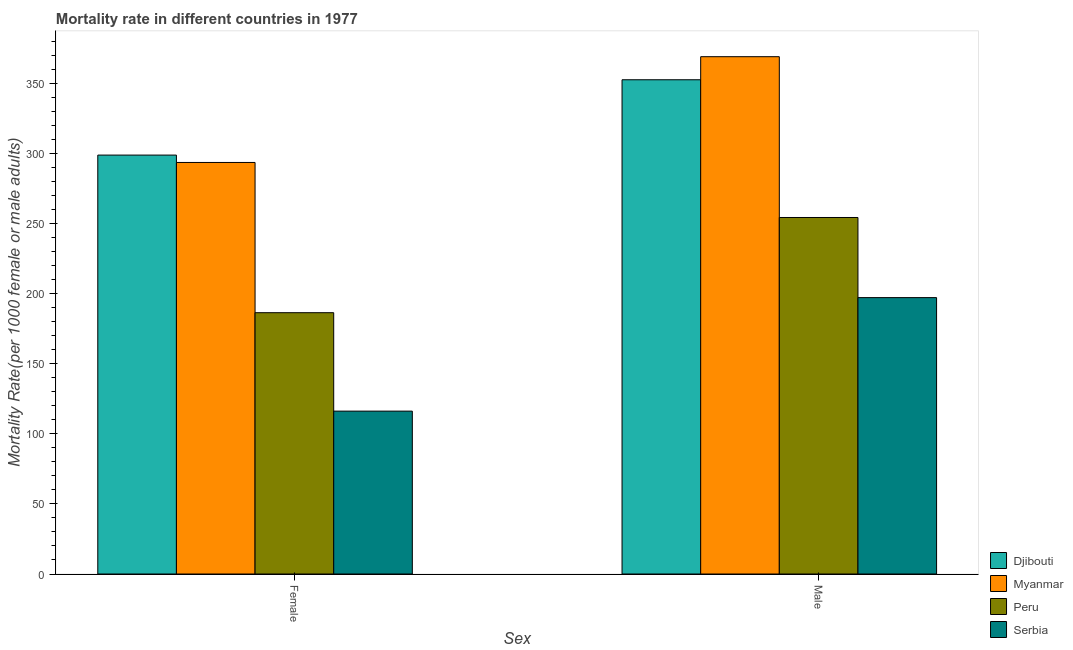Are the number of bars per tick equal to the number of legend labels?
Offer a very short reply. Yes. How many bars are there on the 1st tick from the right?
Offer a terse response. 4. What is the label of the 2nd group of bars from the left?
Provide a short and direct response. Male. What is the female mortality rate in Peru?
Your answer should be very brief. 186.59. Across all countries, what is the maximum female mortality rate?
Make the answer very short. 299.13. Across all countries, what is the minimum female mortality rate?
Provide a short and direct response. 116.3. In which country was the male mortality rate maximum?
Ensure brevity in your answer.  Myanmar. In which country was the female mortality rate minimum?
Provide a succinct answer. Serbia. What is the total female mortality rate in the graph?
Your response must be concise. 895.9. What is the difference between the male mortality rate in Peru and that in Myanmar?
Keep it short and to the point. -114.83. What is the difference between the female mortality rate in Serbia and the male mortality rate in Djibouti?
Provide a succinct answer. -236.64. What is the average male mortality rate per country?
Your answer should be compact. 293.57. What is the difference between the female mortality rate and male mortality rate in Peru?
Your answer should be very brief. -67.99. What is the ratio of the male mortality rate in Myanmar to that in Serbia?
Give a very brief answer. 1.87. What does the 4th bar from the left in Male represents?
Offer a very short reply. Serbia. What does the 2nd bar from the right in Male represents?
Offer a terse response. Peru. How many bars are there?
Your answer should be compact. 8. What is the difference between two consecutive major ticks on the Y-axis?
Your answer should be very brief. 50. Are the values on the major ticks of Y-axis written in scientific E-notation?
Keep it short and to the point. No. Does the graph contain any zero values?
Your response must be concise. No. Does the graph contain grids?
Provide a short and direct response. No. Where does the legend appear in the graph?
Provide a succinct answer. Bottom right. How many legend labels are there?
Keep it short and to the point. 4. How are the legend labels stacked?
Give a very brief answer. Vertical. What is the title of the graph?
Provide a succinct answer. Mortality rate in different countries in 1977. What is the label or title of the X-axis?
Your answer should be compact. Sex. What is the label or title of the Y-axis?
Make the answer very short. Mortality Rate(per 1000 female or male adults). What is the Mortality Rate(per 1000 female or male adults) of Djibouti in Female?
Make the answer very short. 299.13. What is the Mortality Rate(per 1000 female or male adults) in Myanmar in Female?
Make the answer very short. 293.88. What is the Mortality Rate(per 1000 female or male adults) in Peru in Female?
Ensure brevity in your answer.  186.59. What is the Mortality Rate(per 1000 female or male adults) in Serbia in Female?
Make the answer very short. 116.3. What is the Mortality Rate(per 1000 female or male adults) of Djibouti in Male?
Offer a very short reply. 352.94. What is the Mortality Rate(per 1000 female or male adults) of Myanmar in Male?
Offer a very short reply. 369.4. What is the Mortality Rate(per 1000 female or male adults) in Peru in Male?
Provide a succinct answer. 254.57. What is the Mortality Rate(per 1000 female or male adults) in Serbia in Male?
Ensure brevity in your answer.  197.36. Across all Sex, what is the maximum Mortality Rate(per 1000 female or male adults) of Djibouti?
Ensure brevity in your answer.  352.94. Across all Sex, what is the maximum Mortality Rate(per 1000 female or male adults) of Myanmar?
Keep it short and to the point. 369.4. Across all Sex, what is the maximum Mortality Rate(per 1000 female or male adults) in Peru?
Your answer should be very brief. 254.57. Across all Sex, what is the maximum Mortality Rate(per 1000 female or male adults) in Serbia?
Make the answer very short. 197.36. Across all Sex, what is the minimum Mortality Rate(per 1000 female or male adults) of Djibouti?
Keep it short and to the point. 299.13. Across all Sex, what is the minimum Mortality Rate(per 1000 female or male adults) in Myanmar?
Your response must be concise. 293.88. Across all Sex, what is the minimum Mortality Rate(per 1000 female or male adults) of Peru?
Your response must be concise. 186.59. Across all Sex, what is the minimum Mortality Rate(per 1000 female or male adults) in Serbia?
Your answer should be very brief. 116.3. What is the total Mortality Rate(per 1000 female or male adults) in Djibouti in the graph?
Offer a terse response. 652.07. What is the total Mortality Rate(per 1000 female or male adults) in Myanmar in the graph?
Your answer should be very brief. 663.28. What is the total Mortality Rate(per 1000 female or male adults) of Peru in the graph?
Ensure brevity in your answer.  441.16. What is the total Mortality Rate(per 1000 female or male adults) of Serbia in the graph?
Give a very brief answer. 313.65. What is the difference between the Mortality Rate(per 1000 female or male adults) in Djibouti in Female and that in Male?
Provide a succinct answer. -53.8. What is the difference between the Mortality Rate(per 1000 female or male adults) of Myanmar in Female and that in Male?
Your answer should be very brief. -75.52. What is the difference between the Mortality Rate(per 1000 female or male adults) in Peru in Female and that in Male?
Your response must be concise. -67.99. What is the difference between the Mortality Rate(per 1000 female or male adults) of Serbia in Female and that in Male?
Give a very brief answer. -81.06. What is the difference between the Mortality Rate(per 1000 female or male adults) of Djibouti in Female and the Mortality Rate(per 1000 female or male adults) of Myanmar in Male?
Offer a very short reply. -70.27. What is the difference between the Mortality Rate(per 1000 female or male adults) in Djibouti in Female and the Mortality Rate(per 1000 female or male adults) in Peru in Male?
Your answer should be very brief. 44.56. What is the difference between the Mortality Rate(per 1000 female or male adults) in Djibouti in Female and the Mortality Rate(per 1000 female or male adults) in Serbia in Male?
Provide a succinct answer. 101.78. What is the difference between the Mortality Rate(per 1000 female or male adults) in Myanmar in Female and the Mortality Rate(per 1000 female or male adults) in Peru in Male?
Make the answer very short. 39.3. What is the difference between the Mortality Rate(per 1000 female or male adults) in Myanmar in Female and the Mortality Rate(per 1000 female or male adults) in Serbia in Male?
Provide a succinct answer. 96.52. What is the difference between the Mortality Rate(per 1000 female or male adults) in Peru in Female and the Mortality Rate(per 1000 female or male adults) in Serbia in Male?
Give a very brief answer. -10.77. What is the average Mortality Rate(per 1000 female or male adults) of Djibouti per Sex?
Provide a short and direct response. 326.04. What is the average Mortality Rate(per 1000 female or male adults) of Myanmar per Sex?
Ensure brevity in your answer.  331.64. What is the average Mortality Rate(per 1000 female or male adults) in Peru per Sex?
Make the answer very short. 220.58. What is the average Mortality Rate(per 1000 female or male adults) in Serbia per Sex?
Provide a succinct answer. 156.83. What is the difference between the Mortality Rate(per 1000 female or male adults) in Djibouti and Mortality Rate(per 1000 female or male adults) in Myanmar in Female?
Your answer should be compact. 5.26. What is the difference between the Mortality Rate(per 1000 female or male adults) in Djibouti and Mortality Rate(per 1000 female or male adults) in Peru in Female?
Give a very brief answer. 112.55. What is the difference between the Mortality Rate(per 1000 female or male adults) in Djibouti and Mortality Rate(per 1000 female or male adults) in Serbia in Female?
Provide a succinct answer. 182.84. What is the difference between the Mortality Rate(per 1000 female or male adults) in Myanmar and Mortality Rate(per 1000 female or male adults) in Peru in Female?
Give a very brief answer. 107.29. What is the difference between the Mortality Rate(per 1000 female or male adults) of Myanmar and Mortality Rate(per 1000 female or male adults) of Serbia in Female?
Give a very brief answer. 177.58. What is the difference between the Mortality Rate(per 1000 female or male adults) of Peru and Mortality Rate(per 1000 female or male adults) of Serbia in Female?
Your response must be concise. 70.29. What is the difference between the Mortality Rate(per 1000 female or male adults) in Djibouti and Mortality Rate(per 1000 female or male adults) in Myanmar in Male?
Provide a succinct answer. -16.47. What is the difference between the Mortality Rate(per 1000 female or male adults) of Djibouti and Mortality Rate(per 1000 female or male adults) of Peru in Male?
Ensure brevity in your answer.  98.36. What is the difference between the Mortality Rate(per 1000 female or male adults) of Djibouti and Mortality Rate(per 1000 female or male adults) of Serbia in Male?
Your answer should be very brief. 155.58. What is the difference between the Mortality Rate(per 1000 female or male adults) in Myanmar and Mortality Rate(per 1000 female or male adults) in Peru in Male?
Ensure brevity in your answer.  114.83. What is the difference between the Mortality Rate(per 1000 female or male adults) of Myanmar and Mortality Rate(per 1000 female or male adults) of Serbia in Male?
Your response must be concise. 172.04. What is the difference between the Mortality Rate(per 1000 female or male adults) of Peru and Mortality Rate(per 1000 female or male adults) of Serbia in Male?
Offer a very short reply. 57.22. What is the ratio of the Mortality Rate(per 1000 female or male adults) in Djibouti in Female to that in Male?
Provide a short and direct response. 0.85. What is the ratio of the Mortality Rate(per 1000 female or male adults) of Myanmar in Female to that in Male?
Your answer should be very brief. 0.8. What is the ratio of the Mortality Rate(per 1000 female or male adults) of Peru in Female to that in Male?
Provide a succinct answer. 0.73. What is the ratio of the Mortality Rate(per 1000 female or male adults) of Serbia in Female to that in Male?
Your answer should be very brief. 0.59. What is the difference between the highest and the second highest Mortality Rate(per 1000 female or male adults) in Djibouti?
Your answer should be very brief. 53.8. What is the difference between the highest and the second highest Mortality Rate(per 1000 female or male adults) of Myanmar?
Keep it short and to the point. 75.52. What is the difference between the highest and the second highest Mortality Rate(per 1000 female or male adults) in Peru?
Your answer should be compact. 67.99. What is the difference between the highest and the second highest Mortality Rate(per 1000 female or male adults) in Serbia?
Offer a terse response. 81.06. What is the difference between the highest and the lowest Mortality Rate(per 1000 female or male adults) of Djibouti?
Your answer should be compact. 53.8. What is the difference between the highest and the lowest Mortality Rate(per 1000 female or male adults) in Myanmar?
Offer a very short reply. 75.52. What is the difference between the highest and the lowest Mortality Rate(per 1000 female or male adults) of Peru?
Your answer should be compact. 67.99. What is the difference between the highest and the lowest Mortality Rate(per 1000 female or male adults) of Serbia?
Offer a terse response. 81.06. 